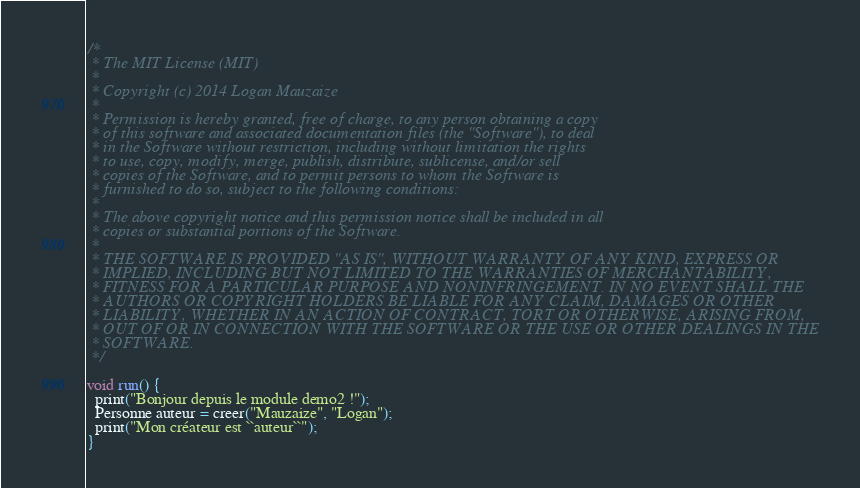Convert code to text. <code><loc_0><loc_0><loc_500><loc_500><_Ceylon_>/*
 * The MIT License (MIT)
 * 
 * Copyright (c) 2014 Logan Mauzaize
 * 
 * Permission is hereby granted, free of charge, to any person obtaining a copy
 * of this software and associated documentation files (the "Software"), to deal
 * in the Software without restriction, including without limitation the rights
 * to use, copy, modify, merge, publish, distribute, sublicense, and/or sell
 * copies of the Software, and to permit persons to whom the Software is
 * furnished to do so, subject to the following conditions:
 *
 * The above copyright notice and this permission notice shall be included in all
 * copies or substantial portions of the Software.
 *
 * THE SOFTWARE IS PROVIDED "AS IS", WITHOUT WARRANTY OF ANY KIND, EXPRESS OR
 * IMPLIED, INCLUDING BUT NOT LIMITED TO THE WARRANTIES OF MERCHANTABILITY,
 * FITNESS FOR A PARTICULAR PURPOSE AND NONINFRINGEMENT. IN NO EVENT SHALL THE
 * AUTHORS OR COPYRIGHT HOLDERS BE LIABLE FOR ANY CLAIM, DAMAGES OR OTHER
 * LIABILITY, WHETHER IN AN ACTION OF CONTRACT, TORT OR OTHERWISE, ARISING FROM,
 * OUT OF OR IN CONNECTION WITH THE SOFTWARE OR THE USE OR OTHER DEALINGS IN THE
 * SOFTWARE.
 */

void run() {
  print("Bonjour depuis le module demo2 !");
  Personne auteur = creer("Mauzaize", "Logan");
  print("Mon créateur est ``auteur``");
}
</code> 